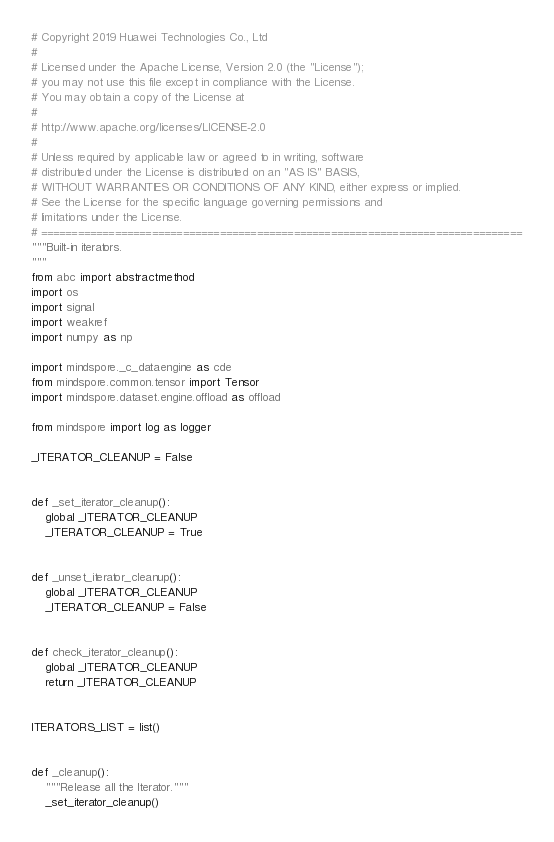<code> <loc_0><loc_0><loc_500><loc_500><_Python_># Copyright 2019 Huawei Technologies Co., Ltd
#
# Licensed under the Apache License, Version 2.0 (the "License");
# you may not use this file except in compliance with the License.
# You may obtain a copy of the License at
#
# http://www.apache.org/licenses/LICENSE-2.0
#
# Unless required by applicable law or agreed to in writing, software
# distributed under the License is distributed on an "AS IS" BASIS,
# WITHOUT WARRANTIES OR CONDITIONS OF ANY KIND, either express or implied.
# See the License for the specific language governing permissions and
# limitations under the License.
# ==============================================================================
"""Built-in iterators.
"""
from abc import abstractmethod
import os
import signal
import weakref
import numpy as np

import mindspore._c_dataengine as cde
from mindspore.common.tensor import Tensor
import mindspore.dataset.engine.offload as offload

from mindspore import log as logger

_ITERATOR_CLEANUP = False


def _set_iterator_cleanup():
    global _ITERATOR_CLEANUP
    _ITERATOR_CLEANUP = True


def _unset_iterator_cleanup():
    global _ITERATOR_CLEANUP
    _ITERATOR_CLEANUP = False


def check_iterator_cleanup():
    global _ITERATOR_CLEANUP
    return _ITERATOR_CLEANUP


ITERATORS_LIST = list()


def _cleanup():
    """Release all the Iterator."""
    _set_iterator_cleanup()</code> 